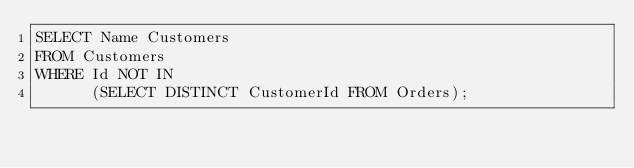Convert code to text. <code><loc_0><loc_0><loc_500><loc_500><_SQL_>SELECT Name Customers
FROM Customers
WHERE Id NOT IN
      (SELECT DISTINCT CustomerId FROM Orders);
</code> 